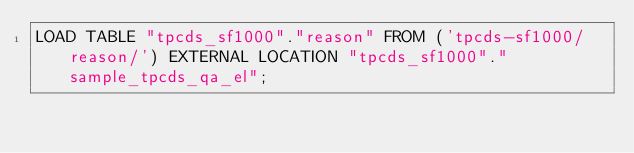Convert code to text. <code><loc_0><loc_0><loc_500><loc_500><_SQL_>LOAD TABLE "tpcds_sf1000"."reason" FROM ('tpcds-sf1000/reason/') EXTERNAL LOCATION "tpcds_sf1000"."sample_tpcds_qa_el";
</code> 